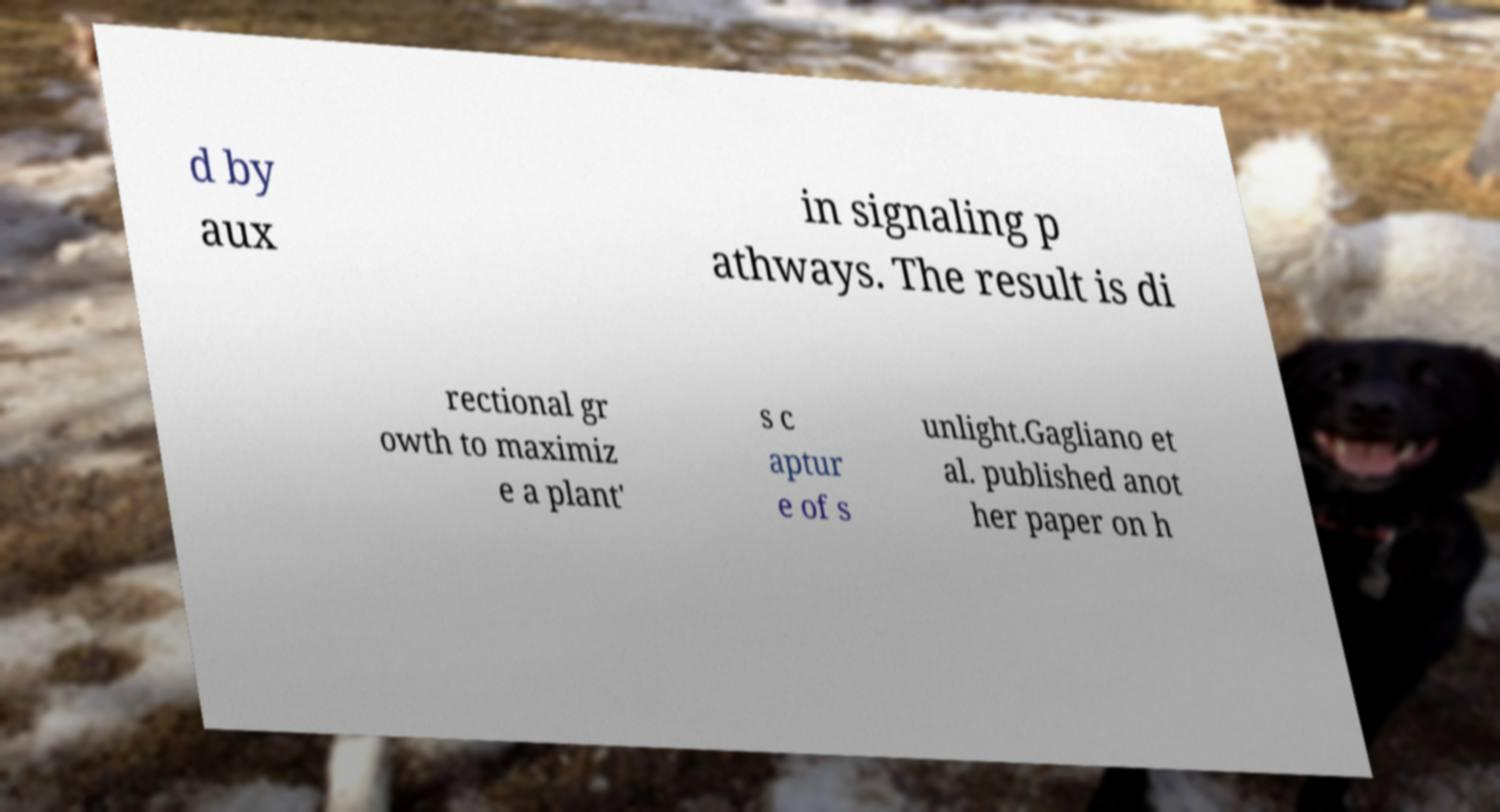Please read and relay the text visible in this image. What does it say? d by aux in signaling p athways. The result is di rectional gr owth to maximiz e a plant' s c aptur e of s unlight.Gagliano et al. published anot her paper on h 